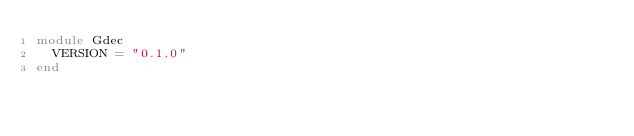<code> <loc_0><loc_0><loc_500><loc_500><_Ruby_>module Gdec
  VERSION = "0.1.0"
end
</code> 